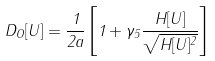<formula> <loc_0><loc_0><loc_500><loc_500>D _ { O } [ U ] = \frac { 1 } { 2 a } \left [ 1 + \gamma _ { 5 } \frac { H [ U ] } { \sqrt { H [ U ] ^ { 2 } } } \right ]</formula> 